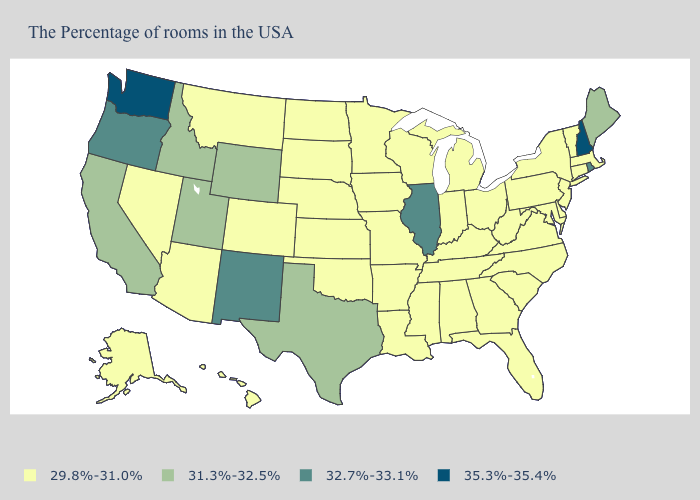What is the lowest value in the USA?
Quick response, please. 29.8%-31.0%. Among the states that border Oregon , does Idaho have the highest value?
Quick response, please. No. Does New Hampshire have the highest value in the USA?
Be succinct. Yes. Does Alaska have the lowest value in the West?
Write a very short answer. Yes. What is the value of Arkansas?
Concise answer only. 29.8%-31.0%. Does California have a lower value than Indiana?
Quick response, please. No. What is the value of Missouri?
Be succinct. 29.8%-31.0%. Which states have the lowest value in the South?
Short answer required. Delaware, Maryland, Virginia, North Carolina, South Carolina, West Virginia, Florida, Georgia, Kentucky, Alabama, Tennessee, Mississippi, Louisiana, Arkansas, Oklahoma. What is the value of Montana?
Be succinct. 29.8%-31.0%. Does Kansas have the highest value in the MidWest?
Concise answer only. No. What is the value of Montana?
Be succinct. 29.8%-31.0%. Among the states that border Oklahoma , does New Mexico have the highest value?
Be succinct. Yes. Name the states that have a value in the range 29.8%-31.0%?
Write a very short answer. Massachusetts, Vermont, Connecticut, New York, New Jersey, Delaware, Maryland, Pennsylvania, Virginia, North Carolina, South Carolina, West Virginia, Ohio, Florida, Georgia, Michigan, Kentucky, Indiana, Alabama, Tennessee, Wisconsin, Mississippi, Louisiana, Missouri, Arkansas, Minnesota, Iowa, Kansas, Nebraska, Oklahoma, South Dakota, North Dakota, Colorado, Montana, Arizona, Nevada, Alaska, Hawaii. Which states have the lowest value in the USA?
Answer briefly. Massachusetts, Vermont, Connecticut, New York, New Jersey, Delaware, Maryland, Pennsylvania, Virginia, North Carolina, South Carolina, West Virginia, Ohio, Florida, Georgia, Michigan, Kentucky, Indiana, Alabama, Tennessee, Wisconsin, Mississippi, Louisiana, Missouri, Arkansas, Minnesota, Iowa, Kansas, Nebraska, Oklahoma, South Dakota, North Dakota, Colorado, Montana, Arizona, Nevada, Alaska, Hawaii. Name the states that have a value in the range 29.8%-31.0%?
Give a very brief answer. Massachusetts, Vermont, Connecticut, New York, New Jersey, Delaware, Maryland, Pennsylvania, Virginia, North Carolina, South Carolina, West Virginia, Ohio, Florida, Georgia, Michigan, Kentucky, Indiana, Alabama, Tennessee, Wisconsin, Mississippi, Louisiana, Missouri, Arkansas, Minnesota, Iowa, Kansas, Nebraska, Oklahoma, South Dakota, North Dakota, Colorado, Montana, Arizona, Nevada, Alaska, Hawaii. 